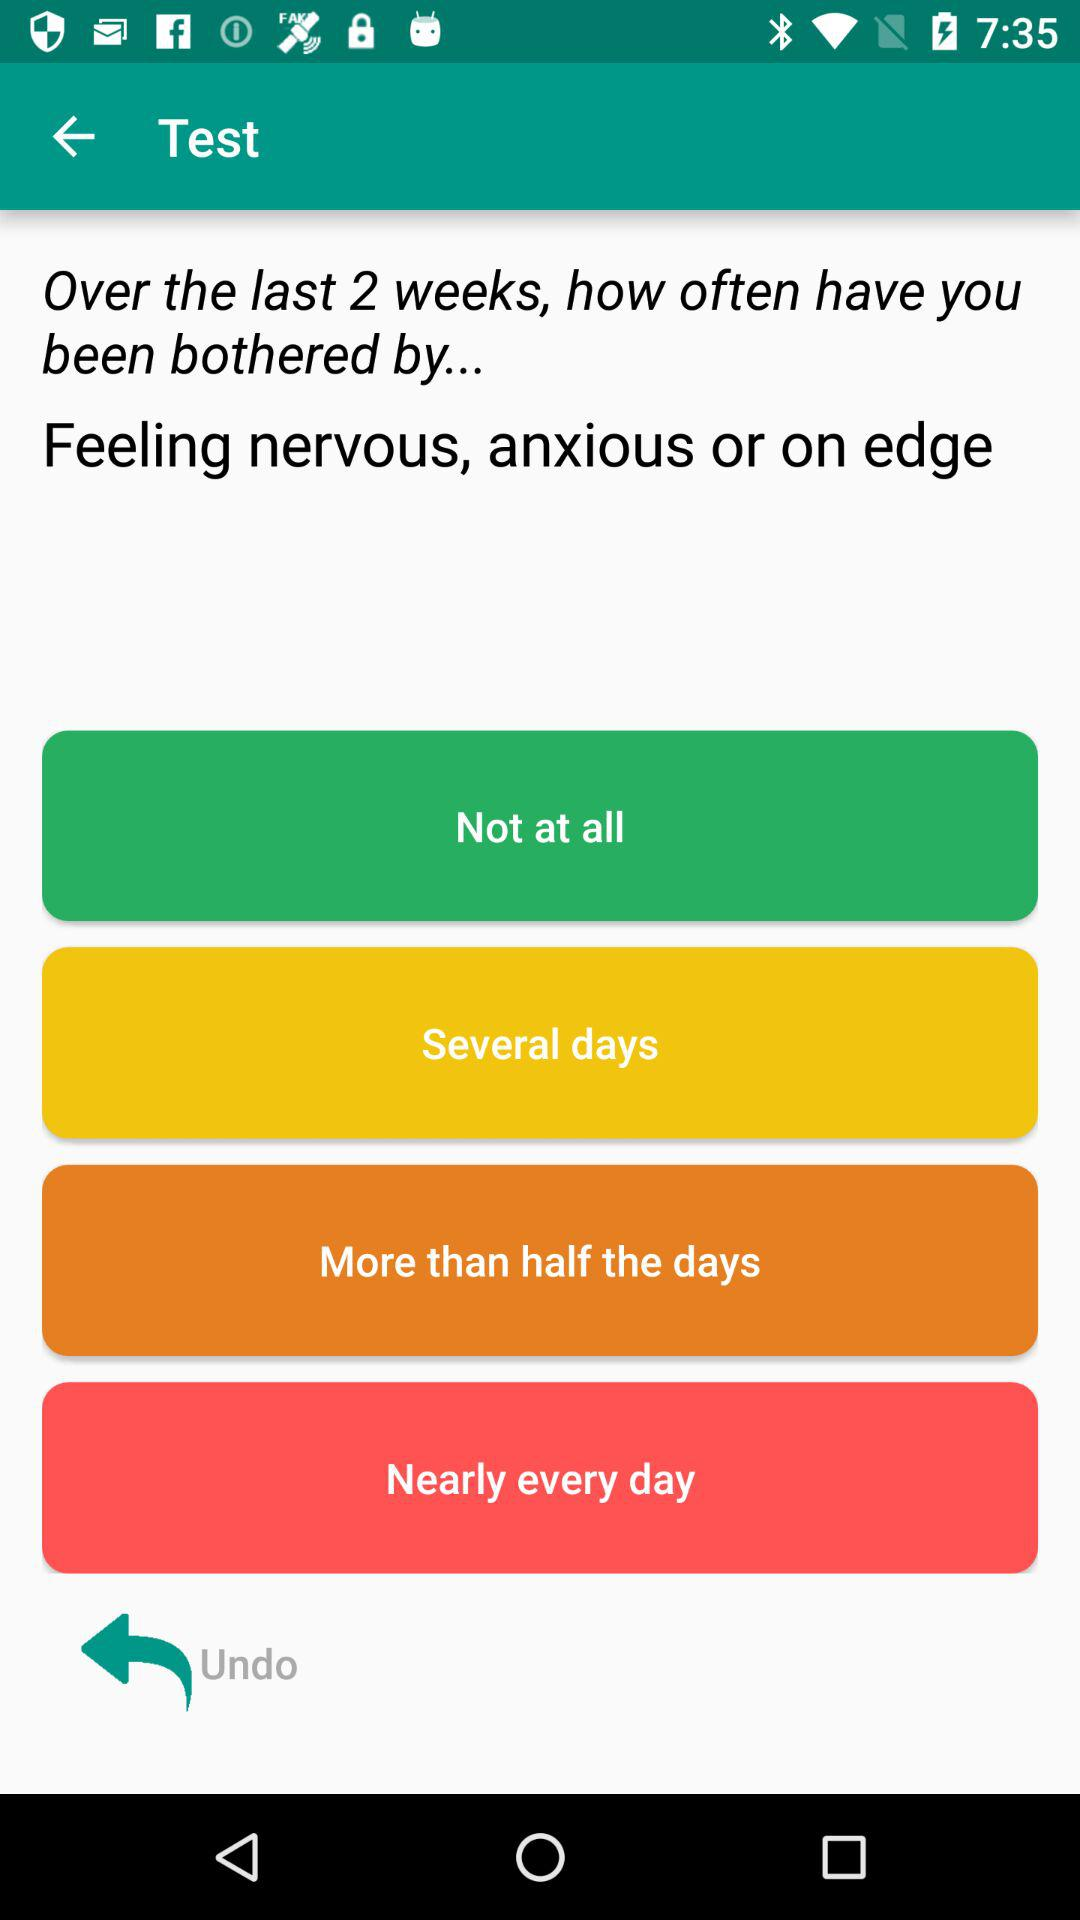Which are the different options? The different options are "Not at all", "Several days", "More than half the days" and "Nearly every day". 